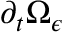Convert formula to latex. <formula><loc_0><loc_0><loc_500><loc_500>\partial _ { t } \Omega _ { \epsilon }</formula> 